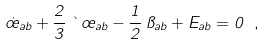<formula> <loc_0><loc_0><loc_500><loc_500>\dot { \sigma } _ { a b } + \frac { 2 } { 3 } \, \theta \, \sigma _ { a b } - \frac { 1 } { 2 } \, \pi _ { a b } + E _ { a b } = 0 \ ,</formula> 